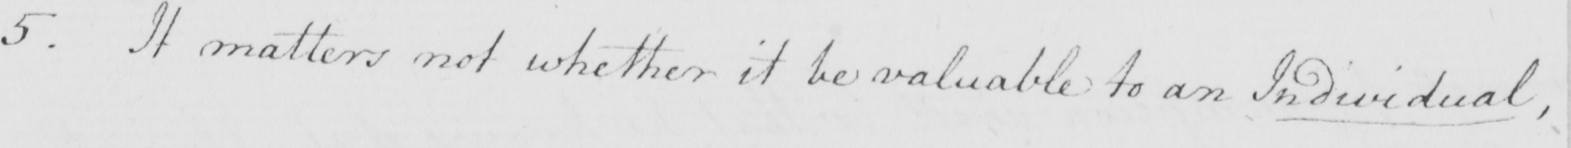Please transcribe the handwritten text in this image. 5 . It matters not whether it be valuable to an Individual , 